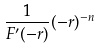Convert formula to latex. <formula><loc_0><loc_0><loc_500><loc_500>\frac { 1 } { F ^ { \prime } ( - r ) } ( - r ) ^ { - n }</formula> 